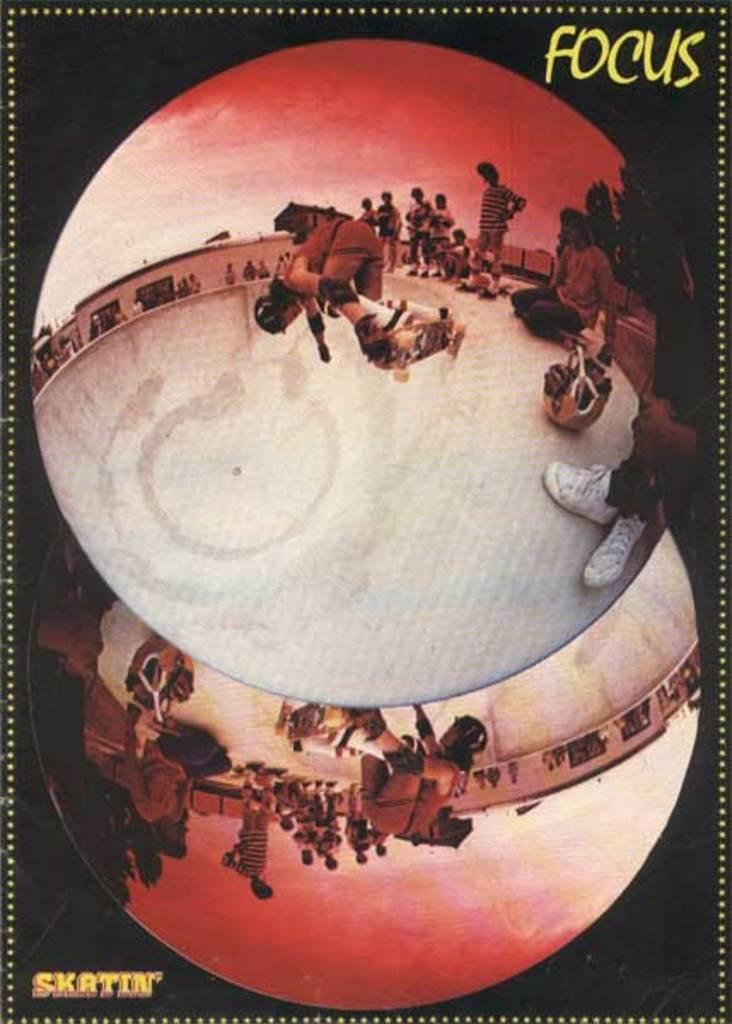Provide a one-sentence caption for the provided image. A poster featuring skateboarders by the brand called Focus. 